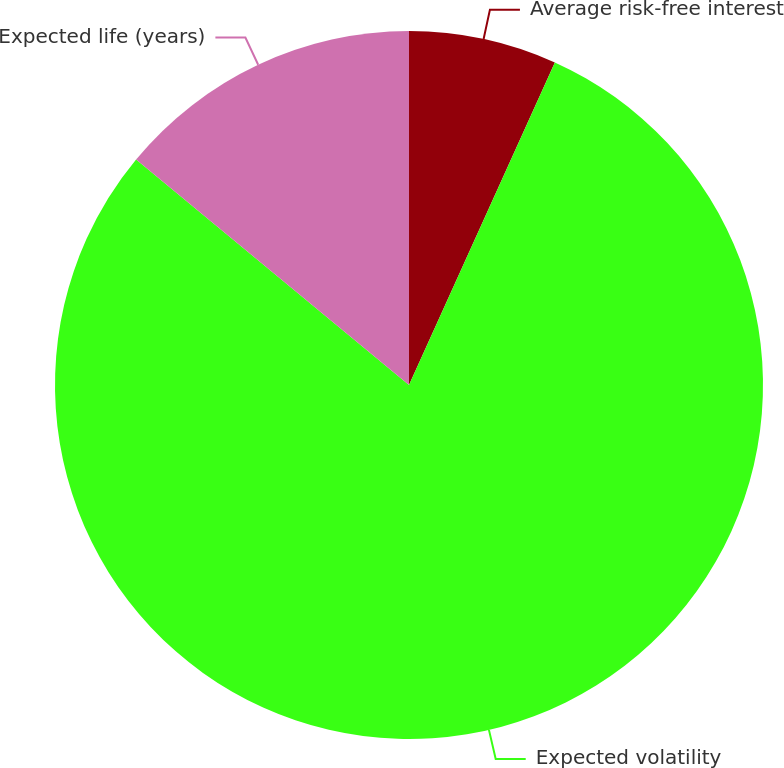Convert chart to OTSL. <chart><loc_0><loc_0><loc_500><loc_500><pie_chart><fcel>Average risk-free interest<fcel>Expected volatility<fcel>Expected life (years)<nl><fcel>6.76%<fcel>79.23%<fcel>14.01%<nl></chart> 